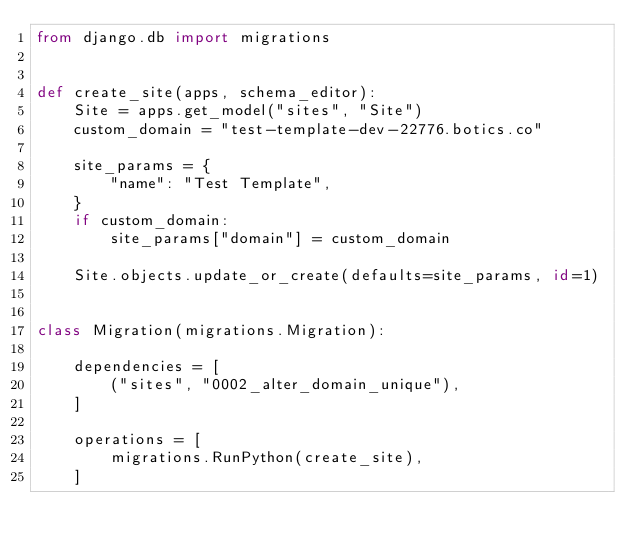<code> <loc_0><loc_0><loc_500><loc_500><_Python_>from django.db import migrations


def create_site(apps, schema_editor):
    Site = apps.get_model("sites", "Site")
    custom_domain = "test-template-dev-22776.botics.co"

    site_params = {
        "name": "Test Template",
    }
    if custom_domain:
        site_params["domain"] = custom_domain

    Site.objects.update_or_create(defaults=site_params, id=1)


class Migration(migrations.Migration):

    dependencies = [
        ("sites", "0002_alter_domain_unique"),
    ]

    operations = [
        migrations.RunPython(create_site),
    ]
</code> 